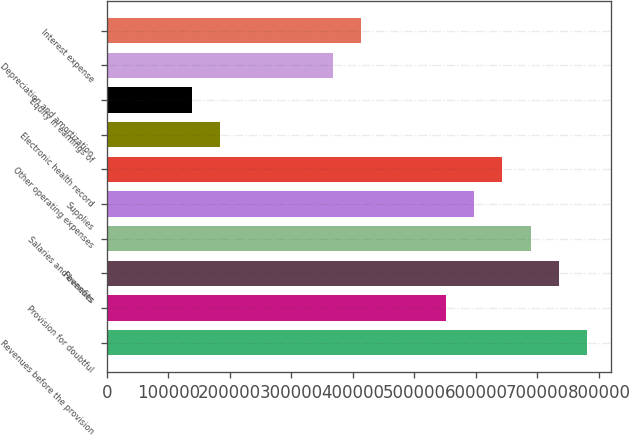Convert chart. <chart><loc_0><loc_0><loc_500><loc_500><bar_chart><fcel>Revenues before the provision<fcel>Provision for doubtful<fcel>Revenues<fcel>Salaries and benefits<fcel>Supplies<fcel>Other operating expenses<fcel>Electronic health record<fcel>Equity in earnings of<fcel>Depreciation and amortization<fcel>Interest expense<nl><fcel>780983<fcel>551283<fcel>735043<fcel>689103<fcel>597223<fcel>643163<fcel>183763<fcel>137823<fcel>367523<fcel>413463<nl></chart> 